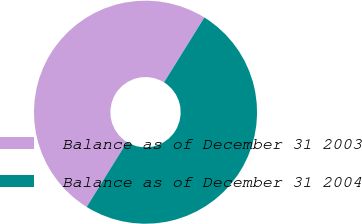<chart> <loc_0><loc_0><loc_500><loc_500><pie_chart><fcel>Balance as of December 31 2003<fcel>Balance as of December 31 2004<nl><fcel>50.0%<fcel>50.0%<nl></chart> 